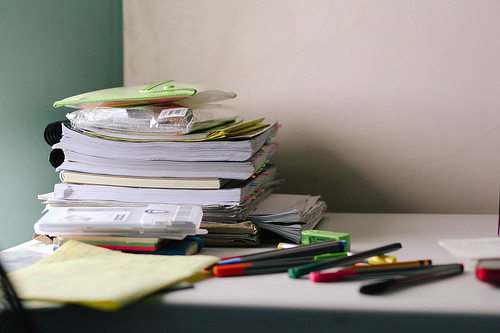<image>
Is the book on the table? Yes. Looking at the image, I can see the book is positioned on top of the table, with the table providing support. 